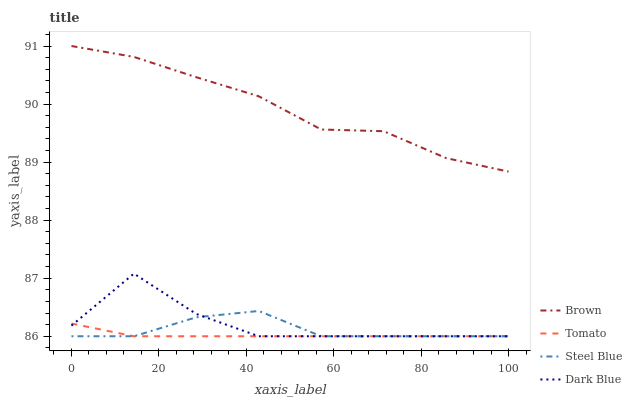Does Tomato have the minimum area under the curve?
Answer yes or no. Yes. Does Brown have the maximum area under the curve?
Answer yes or no. Yes. Does Steel Blue have the minimum area under the curve?
Answer yes or no. No. Does Steel Blue have the maximum area under the curve?
Answer yes or no. No. Is Tomato the smoothest?
Answer yes or no. Yes. Is Dark Blue the roughest?
Answer yes or no. Yes. Is Brown the smoothest?
Answer yes or no. No. Is Brown the roughest?
Answer yes or no. No. Does Brown have the lowest value?
Answer yes or no. No. Does Brown have the highest value?
Answer yes or no. Yes. Does Steel Blue have the highest value?
Answer yes or no. No. Is Steel Blue less than Brown?
Answer yes or no. Yes. Is Brown greater than Dark Blue?
Answer yes or no. Yes. Does Steel Blue intersect Tomato?
Answer yes or no. Yes. Is Steel Blue less than Tomato?
Answer yes or no. No. Is Steel Blue greater than Tomato?
Answer yes or no. No. Does Steel Blue intersect Brown?
Answer yes or no. No. 